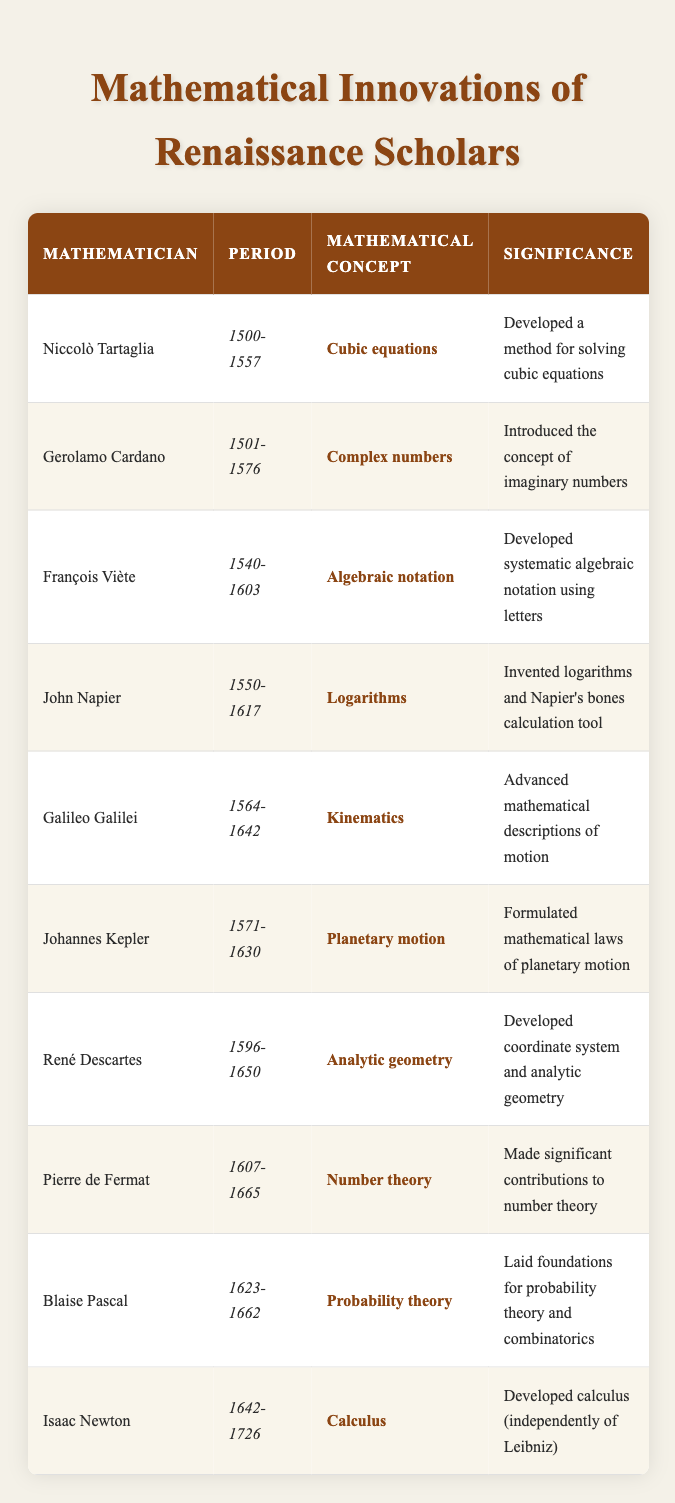What mathematical concept did Niccolò Tartaglia develop? According to the table, Niccolò Tartaglia is noted for developing a method for solving cubic equations.
Answer: Cubic equations Which mathematician introduced the concept of imaginary numbers? From the table, it shows that Gerolamo Cardano introduced the concept of imaginary numbers.
Answer: Gerolamo Cardano How many mathematicians are listed from the period 1600-1700? The mathematicians listed in that period include Pierre de Fermat, Blaise Pascal, and Isaac Newton, totaling three individuals during that time.
Answer: Three Did René Descartes contribute to probability theory? Reviewing the table, René Descartes is associated with analytic geometry, not probability theory, which was advanced by Blaise Pascal.
Answer: No What was the significance of François Viète's work? The table indicates that François Viète developed systematic algebraic notation using letters, which has significant implications for algebra.
Answer: Systematic algebraic notation Which two mathematicians worked on concepts related to motion? The table identifies Galileo Galilei with kinematics, and Johannes Kepler with mathematical laws of planetary motion, thus both contributed to concepts related to motion.
Answer: Galileo Galilei and Johannes Kepler Which mathematical concept is associated with John Napier? The table specifies that John Napier invented logarithms and developed Napier's bones calculation tool.
Answer: Logarithms What is the relationship between Blaise Pascal and combinatorics? The table notes that Blaise Pascal laid the foundations for probability theory and combinatorics, indicating a direct connection between him and the field of combinatorics.
Answer: He laid foundations for combinatorics List the mathematicians who introduced concepts after 1600. The table includes Pierre de Fermat, Blaise Pascal, and Isaac Newton; thus these three mathematicians introduced concepts after 1600.
Answer: Pierre de Fermat, Blaise Pascal, Isaac Newton 